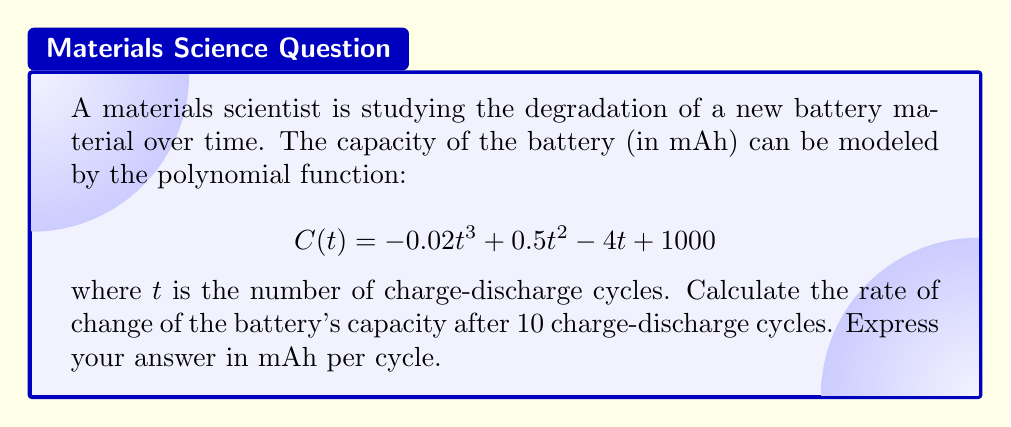Help me with this question. To find the rate of change of the battery's capacity after 10 charge-discharge cycles, we need to follow these steps:

1) The rate of change of capacity with respect to the number of cycles is given by the derivative of the capacity function $C(t)$.

2) Let's find the derivative of $C(t)$:
   $$C'(t) = \frac{d}{dt}[-0.02t^3 + 0.5t^2 - 4t + 1000]$$
   $$C'(t) = -0.06t^2 + t - 4$$

3) This derivative function $C'(t)$ represents the instantaneous rate of change of capacity at any given cycle $t$.

4) To find the rate of change after 10 cycles, we need to evaluate $C'(t)$ at $t = 10$:
   $$C'(10) = -0.06(10)^2 + 10 - 4$$
   $$= -0.06(100) + 10 - 4$$
   $$= -6 + 10 - 4$$
   $$= 0$$

5) The units of this rate of change are mAh per cycle, as we're measuring how the capacity (in mAh) changes with each cycle.
Answer: 0 mAh per cycle 